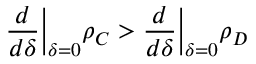Convert formula to latex. <formula><loc_0><loc_0><loc_500><loc_500>\frac { d } { d \delta } \left | _ { \delta = 0 } \rho _ { C } > \frac { d } { d \delta } \right | _ { \delta = 0 } \rho _ { D }</formula> 